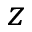Convert formula to latex. <formula><loc_0><loc_0><loc_500><loc_500>z</formula> 